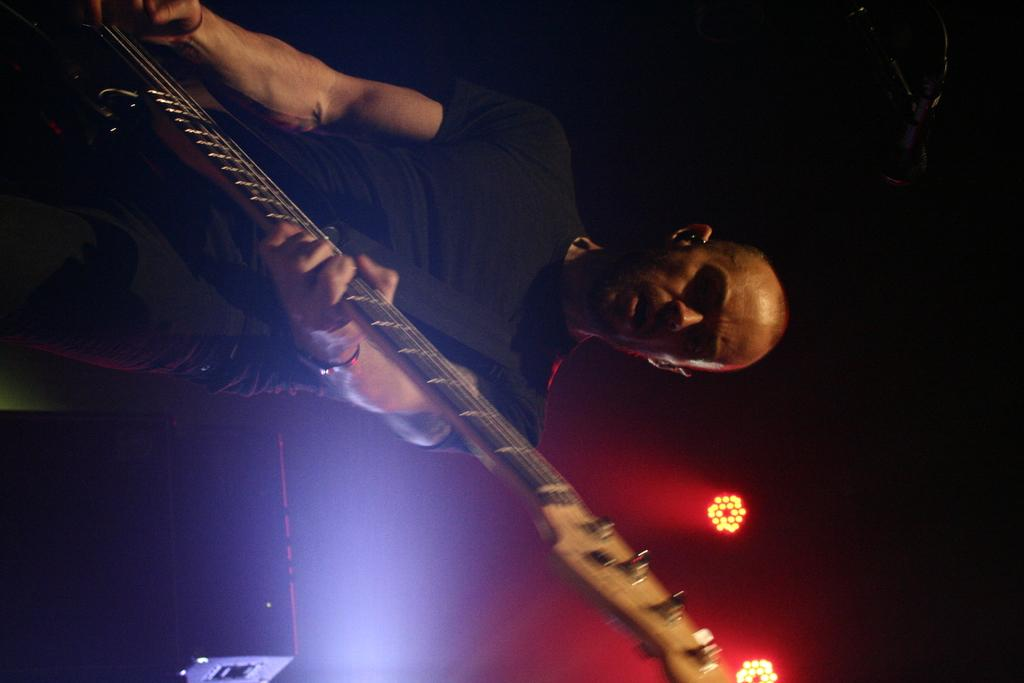What is the person in the image doing? There is a person playing a guitar in the image. What object is located at the bottom of the image? There is a speaker at the bottom of the image. What can be seen towards the right side of the image? There are focus lights towards the right side of the image. How would you describe the lighting in the top part of the image? The top part of the image is dark. What type of plantation can be seen in the background of the image? There is no plantation present in the image. What color is the celery that the person is holding in the image? There is no celery present in the image. 